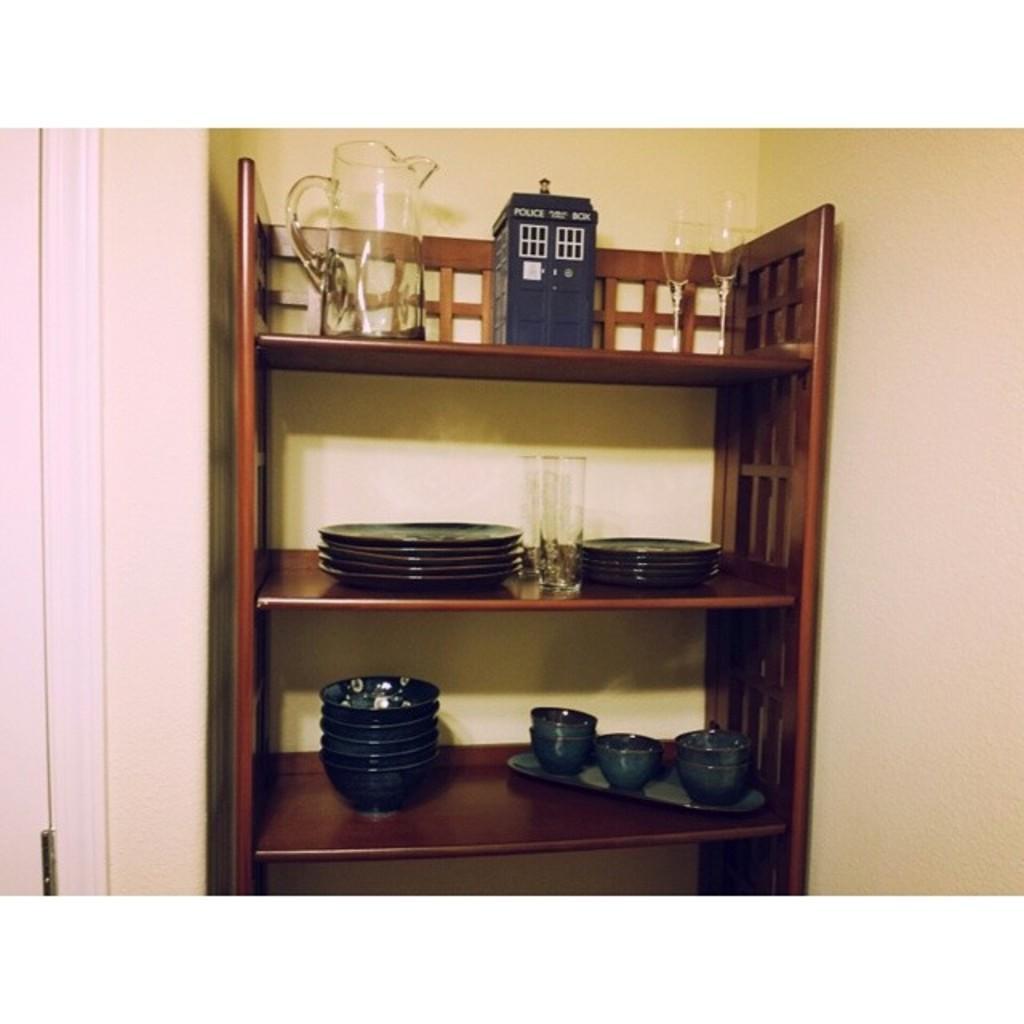Can you describe this image briefly? There is a glass jug, two glasses and a box is kept on the top shelf. There are plates and a glass arranged on the second shelf. There are cups arranged on a tray and the bowls arranged on the third shelf. In the background, there is wall. 